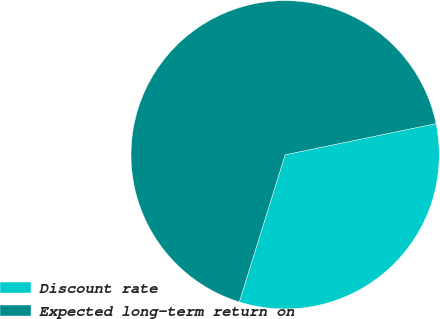<chart> <loc_0><loc_0><loc_500><loc_500><pie_chart><fcel>Discount rate<fcel>Expected long-term return on<nl><fcel>33.05%<fcel>66.95%<nl></chart> 